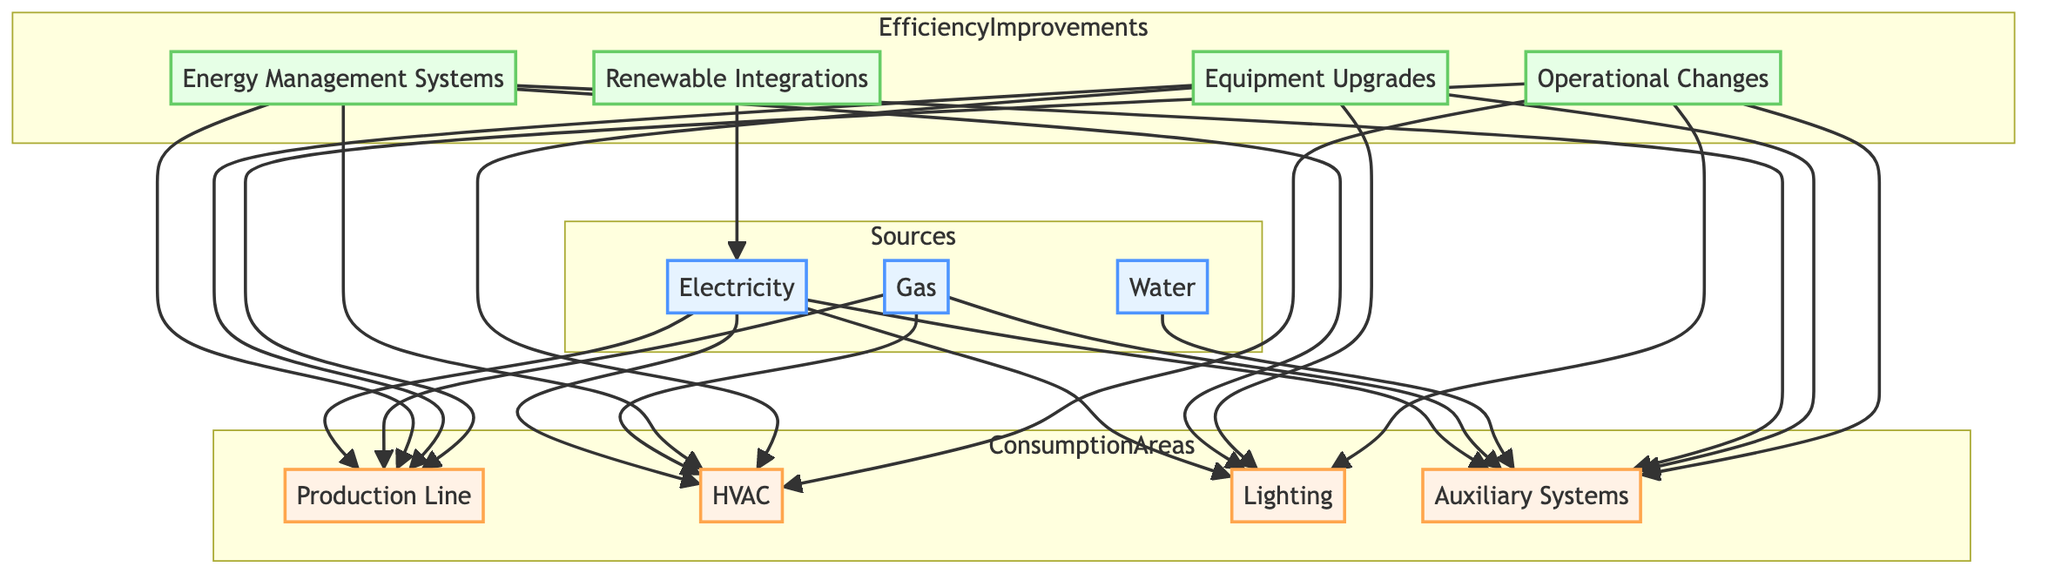What are the three sources of energy in the diagram? The diagram lists three energy sources: Electricity, Gas, and Water.
Answer: Electricity, Gas, Water Which consumption area utilizes water as an energy source? The Auxiliary Systems is the only consumption area that is directly linked to Water as an energy source in the diagram.
Answer: Auxiliary Systems How many types of efficiency improvements are presented in the diagram? There are four types of efficiency improvements mentioned in the Efficiency Improvements subgraph: Energy Management Systems, Equipment Upgrades, Operational Changes, and Renewable Integrations.
Answer: 4 Which energy source is used by both the Production Line and HVAC? Both the Production Line and HVAC areas utilize Electricity and Gas as their energy sources according to the connections shown in the diagram.
Answer: Electricity, Gas What energy source connects directly to the Production Line? The connections from the Sources to the Production Line indicate that both Electricity and Gas flow into this area, as shown in the diagram.
Answer: Electricity, Gas Which efficiency improvement relates to renewable energy? Renewable Integrations focus on utilizing renewable energy sources like Solar Arrays and Wind Power Systems as indicated in the diagram.
Answer: Renewable Integrations What component is part of the HVAC consumption area? The HVAC area includes Heating Units, Cooling Units, and Ventilation Units as components, as noted in their description in the Consumption Areas of the diagram.
Answer: Heating Units, Cooling Units, Ventilation Units How many consumption areas receive electricity? There are four consumption areas that utilize Electricity: Production Line, HVAC, Lighting, and Auxiliary Systems, confirming their interconnectedness with the Electricity source in the diagram.
Answer: 4 